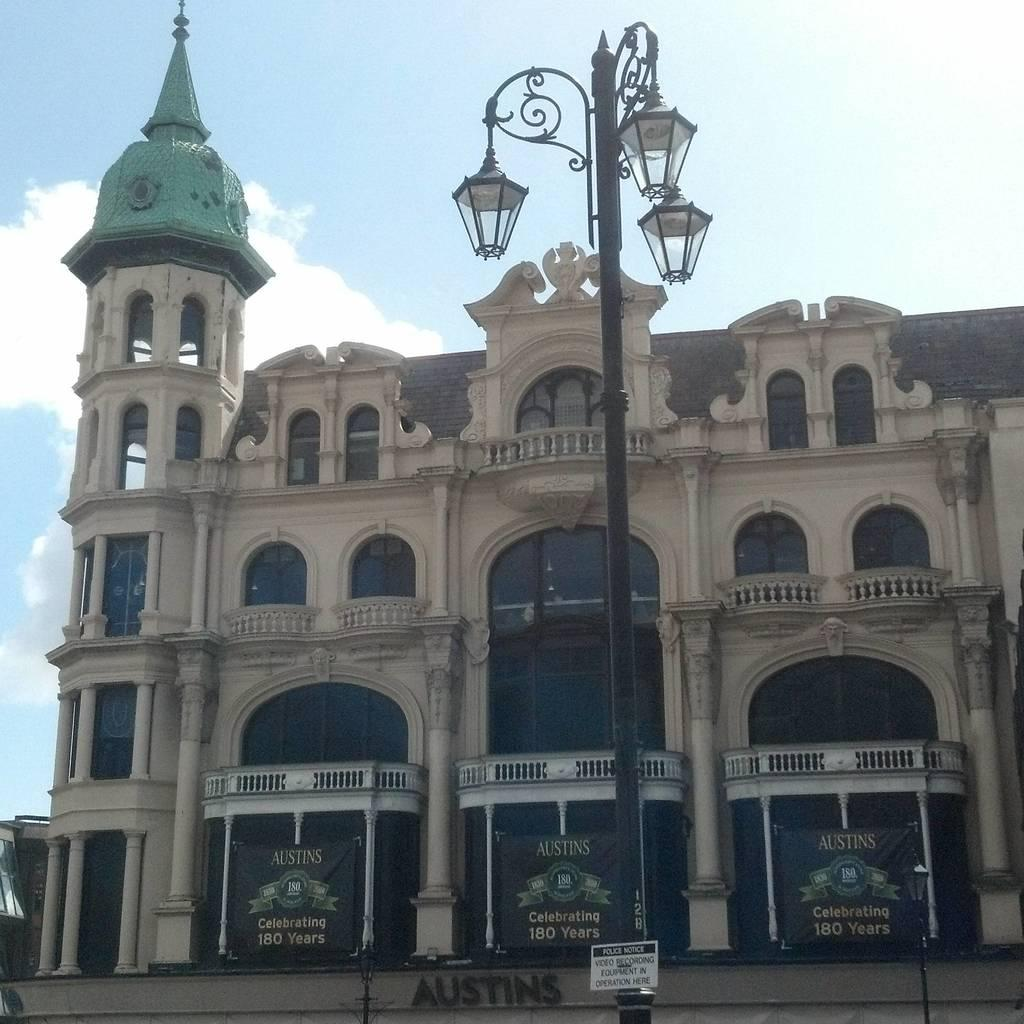<image>
Relay a brief, clear account of the picture shown. A large building with three fire trucks with the name austins on top is park underneath. 